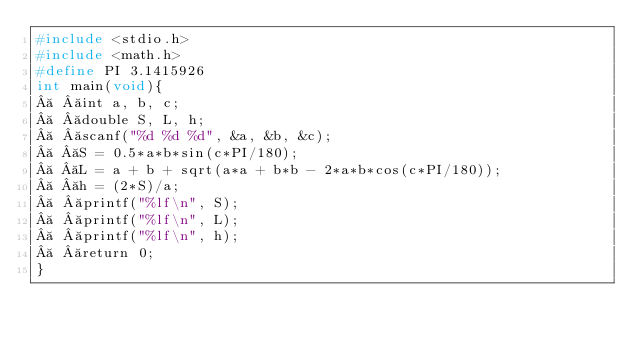Convert code to text. <code><loc_0><loc_0><loc_500><loc_500><_C_>#include <stdio.h>
#include <math.h>
#define PI 3.1415926
int main(void){
   int a, b, c;
   double S, L, h;
   scanf("%d %d %d", &a, &b, &c);
   S = 0.5*a*b*sin(c*PI/180);
   L = a + b + sqrt(a*a + b*b - 2*a*b*cos(c*PI/180));
   h = (2*S)/a;
   printf("%lf\n", S);
   printf("%lf\n", L);
   printf("%lf\n", h);
   return 0;
}
</code> 